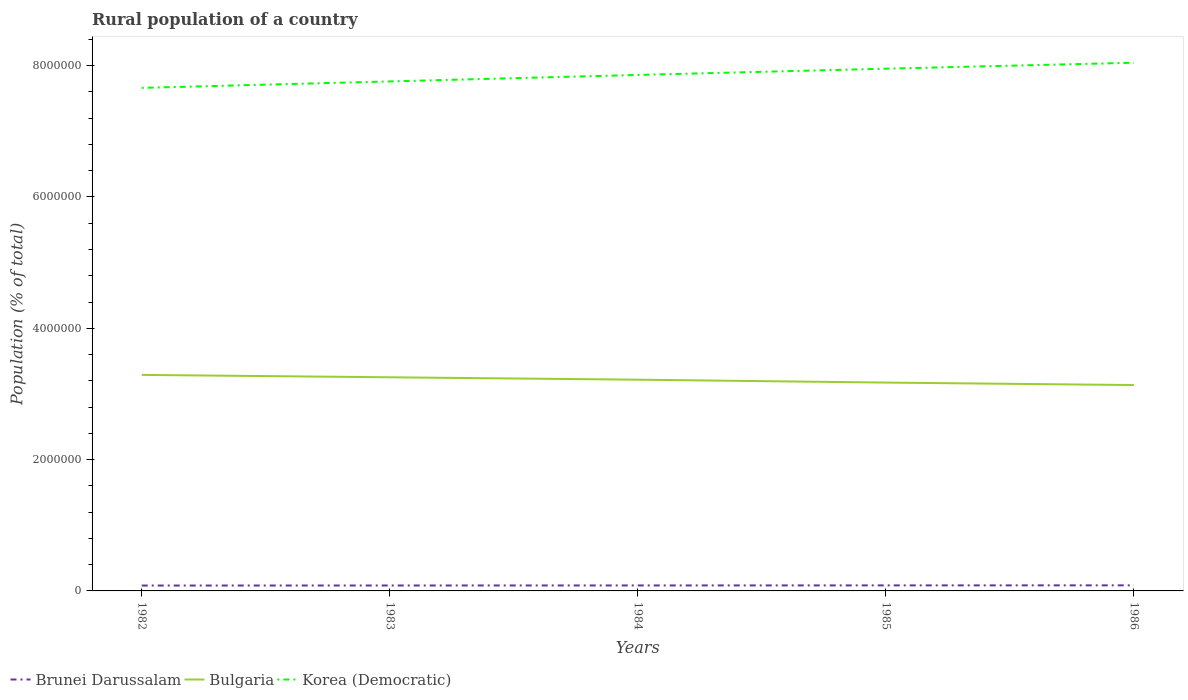Across all years, what is the maximum rural population in Bulgaria?
Give a very brief answer. 3.14e+06. In which year was the rural population in Bulgaria maximum?
Your answer should be very brief. 1986. What is the total rural population in Bulgaria in the graph?
Make the answer very short. 1.55e+05. What is the difference between the highest and the second highest rural population in Bulgaria?
Your answer should be compact. 1.55e+05. How many lines are there?
Your response must be concise. 3. How many years are there in the graph?
Your answer should be very brief. 5. What is the difference between two consecutive major ticks on the Y-axis?
Provide a succinct answer. 2.00e+06. Are the values on the major ticks of Y-axis written in scientific E-notation?
Your response must be concise. No. How many legend labels are there?
Your answer should be compact. 3. What is the title of the graph?
Give a very brief answer. Rural population of a country. What is the label or title of the Y-axis?
Keep it short and to the point. Population (% of total). What is the Population (% of total) of Brunei Darussalam in 1982?
Your answer should be compact. 8.20e+04. What is the Population (% of total) of Bulgaria in 1982?
Make the answer very short. 3.29e+06. What is the Population (% of total) in Korea (Democratic) in 1982?
Provide a succinct answer. 7.66e+06. What is the Population (% of total) of Brunei Darussalam in 1983?
Make the answer very short. 8.27e+04. What is the Population (% of total) of Bulgaria in 1983?
Keep it short and to the point. 3.25e+06. What is the Population (% of total) in Korea (Democratic) in 1983?
Your response must be concise. 7.76e+06. What is the Population (% of total) of Brunei Darussalam in 1984?
Your answer should be very brief. 8.35e+04. What is the Population (% of total) in Bulgaria in 1984?
Your response must be concise. 3.22e+06. What is the Population (% of total) of Korea (Democratic) in 1984?
Your answer should be very brief. 7.86e+06. What is the Population (% of total) in Brunei Darussalam in 1985?
Offer a terse response. 8.42e+04. What is the Population (% of total) of Bulgaria in 1985?
Your answer should be very brief. 3.17e+06. What is the Population (% of total) in Korea (Democratic) in 1985?
Give a very brief answer. 7.95e+06. What is the Population (% of total) in Brunei Darussalam in 1986?
Provide a short and direct response. 8.49e+04. What is the Population (% of total) in Bulgaria in 1986?
Give a very brief answer. 3.14e+06. What is the Population (% of total) of Korea (Democratic) in 1986?
Ensure brevity in your answer.  8.04e+06. Across all years, what is the maximum Population (% of total) in Brunei Darussalam?
Give a very brief answer. 8.49e+04. Across all years, what is the maximum Population (% of total) of Bulgaria?
Make the answer very short. 3.29e+06. Across all years, what is the maximum Population (% of total) of Korea (Democratic)?
Ensure brevity in your answer.  8.04e+06. Across all years, what is the minimum Population (% of total) of Brunei Darussalam?
Provide a short and direct response. 8.20e+04. Across all years, what is the minimum Population (% of total) of Bulgaria?
Keep it short and to the point. 3.14e+06. Across all years, what is the minimum Population (% of total) of Korea (Democratic)?
Keep it short and to the point. 7.66e+06. What is the total Population (% of total) in Brunei Darussalam in the graph?
Provide a short and direct response. 4.17e+05. What is the total Population (% of total) of Bulgaria in the graph?
Your response must be concise. 1.61e+07. What is the total Population (% of total) in Korea (Democratic) in the graph?
Your answer should be compact. 3.93e+07. What is the difference between the Population (% of total) in Brunei Darussalam in 1982 and that in 1983?
Offer a terse response. -777. What is the difference between the Population (% of total) of Bulgaria in 1982 and that in 1983?
Give a very brief answer. 3.64e+04. What is the difference between the Population (% of total) of Korea (Democratic) in 1982 and that in 1983?
Provide a short and direct response. -9.83e+04. What is the difference between the Population (% of total) of Brunei Darussalam in 1982 and that in 1984?
Offer a terse response. -1508. What is the difference between the Population (% of total) in Bulgaria in 1982 and that in 1984?
Ensure brevity in your answer.  7.32e+04. What is the difference between the Population (% of total) in Korea (Democratic) in 1982 and that in 1984?
Keep it short and to the point. -1.97e+05. What is the difference between the Population (% of total) of Brunei Darussalam in 1982 and that in 1985?
Keep it short and to the point. -2242. What is the difference between the Population (% of total) in Bulgaria in 1982 and that in 1985?
Give a very brief answer. 1.17e+05. What is the difference between the Population (% of total) of Korea (Democratic) in 1982 and that in 1985?
Provide a succinct answer. -2.92e+05. What is the difference between the Population (% of total) in Brunei Darussalam in 1982 and that in 1986?
Make the answer very short. -2976. What is the difference between the Population (% of total) of Bulgaria in 1982 and that in 1986?
Provide a succinct answer. 1.55e+05. What is the difference between the Population (% of total) in Korea (Democratic) in 1982 and that in 1986?
Ensure brevity in your answer.  -3.83e+05. What is the difference between the Population (% of total) in Brunei Darussalam in 1983 and that in 1984?
Give a very brief answer. -731. What is the difference between the Population (% of total) in Bulgaria in 1983 and that in 1984?
Keep it short and to the point. 3.68e+04. What is the difference between the Population (% of total) in Korea (Democratic) in 1983 and that in 1984?
Give a very brief answer. -9.88e+04. What is the difference between the Population (% of total) in Brunei Darussalam in 1983 and that in 1985?
Make the answer very short. -1465. What is the difference between the Population (% of total) of Bulgaria in 1983 and that in 1985?
Provide a succinct answer. 8.09e+04. What is the difference between the Population (% of total) of Korea (Democratic) in 1983 and that in 1985?
Your answer should be very brief. -1.94e+05. What is the difference between the Population (% of total) of Brunei Darussalam in 1983 and that in 1986?
Offer a very short reply. -2199. What is the difference between the Population (% of total) in Bulgaria in 1983 and that in 1986?
Provide a short and direct response. 1.18e+05. What is the difference between the Population (% of total) of Korea (Democratic) in 1983 and that in 1986?
Keep it short and to the point. -2.85e+05. What is the difference between the Population (% of total) of Brunei Darussalam in 1984 and that in 1985?
Make the answer very short. -734. What is the difference between the Population (% of total) in Bulgaria in 1984 and that in 1985?
Your answer should be very brief. 4.40e+04. What is the difference between the Population (% of total) in Korea (Democratic) in 1984 and that in 1985?
Provide a short and direct response. -9.53e+04. What is the difference between the Population (% of total) in Brunei Darussalam in 1984 and that in 1986?
Ensure brevity in your answer.  -1468. What is the difference between the Population (% of total) of Bulgaria in 1984 and that in 1986?
Offer a very short reply. 8.15e+04. What is the difference between the Population (% of total) of Korea (Democratic) in 1984 and that in 1986?
Offer a terse response. -1.86e+05. What is the difference between the Population (% of total) in Brunei Darussalam in 1985 and that in 1986?
Provide a succinct answer. -734. What is the difference between the Population (% of total) of Bulgaria in 1985 and that in 1986?
Provide a succinct answer. 3.75e+04. What is the difference between the Population (% of total) in Korea (Democratic) in 1985 and that in 1986?
Provide a succinct answer. -9.08e+04. What is the difference between the Population (% of total) of Brunei Darussalam in 1982 and the Population (% of total) of Bulgaria in 1983?
Keep it short and to the point. -3.17e+06. What is the difference between the Population (% of total) of Brunei Darussalam in 1982 and the Population (% of total) of Korea (Democratic) in 1983?
Provide a succinct answer. -7.68e+06. What is the difference between the Population (% of total) of Bulgaria in 1982 and the Population (% of total) of Korea (Democratic) in 1983?
Your answer should be very brief. -4.47e+06. What is the difference between the Population (% of total) in Brunei Darussalam in 1982 and the Population (% of total) in Bulgaria in 1984?
Ensure brevity in your answer.  -3.14e+06. What is the difference between the Population (% of total) in Brunei Darussalam in 1982 and the Population (% of total) in Korea (Democratic) in 1984?
Provide a succinct answer. -7.78e+06. What is the difference between the Population (% of total) in Bulgaria in 1982 and the Population (% of total) in Korea (Democratic) in 1984?
Provide a succinct answer. -4.57e+06. What is the difference between the Population (% of total) in Brunei Darussalam in 1982 and the Population (% of total) in Bulgaria in 1985?
Provide a short and direct response. -3.09e+06. What is the difference between the Population (% of total) of Brunei Darussalam in 1982 and the Population (% of total) of Korea (Democratic) in 1985?
Your response must be concise. -7.87e+06. What is the difference between the Population (% of total) in Bulgaria in 1982 and the Population (% of total) in Korea (Democratic) in 1985?
Your answer should be very brief. -4.66e+06. What is the difference between the Population (% of total) in Brunei Darussalam in 1982 and the Population (% of total) in Bulgaria in 1986?
Offer a terse response. -3.05e+06. What is the difference between the Population (% of total) in Brunei Darussalam in 1982 and the Population (% of total) in Korea (Democratic) in 1986?
Keep it short and to the point. -7.96e+06. What is the difference between the Population (% of total) of Bulgaria in 1982 and the Population (% of total) of Korea (Democratic) in 1986?
Ensure brevity in your answer.  -4.75e+06. What is the difference between the Population (% of total) in Brunei Darussalam in 1983 and the Population (% of total) in Bulgaria in 1984?
Offer a terse response. -3.13e+06. What is the difference between the Population (% of total) in Brunei Darussalam in 1983 and the Population (% of total) in Korea (Democratic) in 1984?
Your response must be concise. -7.78e+06. What is the difference between the Population (% of total) of Bulgaria in 1983 and the Population (% of total) of Korea (Democratic) in 1984?
Keep it short and to the point. -4.60e+06. What is the difference between the Population (% of total) in Brunei Darussalam in 1983 and the Population (% of total) in Bulgaria in 1985?
Your answer should be compact. -3.09e+06. What is the difference between the Population (% of total) in Brunei Darussalam in 1983 and the Population (% of total) in Korea (Democratic) in 1985?
Offer a very short reply. -7.87e+06. What is the difference between the Population (% of total) in Bulgaria in 1983 and the Population (% of total) in Korea (Democratic) in 1985?
Offer a terse response. -4.70e+06. What is the difference between the Population (% of total) of Brunei Darussalam in 1983 and the Population (% of total) of Bulgaria in 1986?
Make the answer very short. -3.05e+06. What is the difference between the Population (% of total) in Brunei Darussalam in 1983 and the Population (% of total) in Korea (Democratic) in 1986?
Your answer should be compact. -7.96e+06. What is the difference between the Population (% of total) of Bulgaria in 1983 and the Population (% of total) of Korea (Democratic) in 1986?
Offer a terse response. -4.79e+06. What is the difference between the Population (% of total) of Brunei Darussalam in 1984 and the Population (% of total) of Bulgaria in 1985?
Keep it short and to the point. -3.09e+06. What is the difference between the Population (% of total) of Brunei Darussalam in 1984 and the Population (% of total) of Korea (Democratic) in 1985?
Offer a very short reply. -7.87e+06. What is the difference between the Population (% of total) of Bulgaria in 1984 and the Population (% of total) of Korea (Democratic) in 1985?
Your response must be concise. -4.74e+06. What is the difference between the Population (% of total) of Brunei Darussalam in 1984 and the Population (% of total) of Bulgaria in 1986?
Ensure brevity in your answer.  -3.05e+06. What is the difference between the Population (% of total) in Brunei Darussalam in 1984 and the Population (% of total) in Korea (Democratic) in 1986?
Provide a succinct answer. -7.96e+06. What is the difference between the Population (% of total) in Bulgaria in 1984 and the Population (% of total) in Korea (Democratic) in 1986?
Make the answer very short. -4.83e+06. What is the difference between the Population (% of total) in Brunei Darussalam in 1985 and the Population (% of total) in Bulgaria in 1986?
Offer a very short reply. -3.05e+06. What is the difference between the Population (% of total) in Brunei Darussalam in 1985 and the Population (% of total) in Korea (Democratic) in 1986?
Your answer should be compact. -7.96e+06. What is the difference between the Population (% of total) in Bulgaria in 1985 and the Population (% of total) in Korea (Democratic) in 1986?
Offer a very short reply. -4.87e+06. What is the average Population (% of total) of Brunei Darussalam per year?
Your response must be concise. 8.35e+04. What is the average Population (% of total) in Bulgaria per year?
Your answer should be very brief. 3.21e+06. What is the average Population (% of total) of Korea (Democratic) per year?
Offer a very short reply. 7.86e+06. In the year 1982, what is the difference between the Population (% of total) in Brunei Darussalam and Population (% of total) in Bulgaria?
Offer a terse response. -3.21e+06. In the year 1982, what is the difference between the Population (% of total) in Brunei Darussalam and Population (% of total) in Korea (Democratic)?
Your answer should be very brief. -7.58e+06. In the year 1982, what is the difference between the Population (% of total) of Bulgaria and Population (% of total) of Korea (Democratic)?
Ensure brevity in your answer.  -4.37e+06. In the year 1983, what is the difference between the Population (% of total) in Brunei Darussalam and Population (% of total) in Bulgaria?
Give a very brief answer. -3.17e+06. In the year 1983, what is the difference between the Population (% of total) of Brunei Darussalam and Population (% of total) of Korea (Democratic)?
Provide a succinct answer. -7.68e+06. In the year 1983, what is the difference between the Population (% of total) of Bulgaria and Population (% of total) of Korea (Democratic)?
Provide a succinct answer. -4.51e+06. In the year 1984, what is the difference between the Population (% of total) of Brunei Darussalam and Population (% of total) of Bulgaria?
Your answer should be compact. -3.13e+06. In the year 1984, what is the difference between the Population (% of total) of Brunei Darussalam and Population (% of total) of Korea (Democratic)?
Provide a succinct answer. -7.77e+06. In the year 1984, what is the difference between the Population (% of total) of Bulgaria and Population (% of total) of Korea (Democratic)?
Your response must be concise. -4.64e+06. In the year 1985, what is the difference between the Population (% of total) in Brunei Darussalam and Population (% of total) in Bulgaria?
Offer a very short reply. -3.09e+06. In the year 1985, what is the difference between the Population (% of total) of Brunei Darussalam and Population (% of total) of Korea (Democratic)?
Ensure brevity in your answer.  -7.87e+06. In the year 1985, what is the difference between the Population (% of total) in Bulgaria and Population (% of total) in Korea (Democratic)?
Provide a succinct answer. -4.78e+06. In the year 1986, what is the difference between the Population (% of total) in Brunei Darussalam and Population (% of total) in Bulgaria?
Your response must be concise. -3.05e+06. In the year 1986, what is the difference between the Population (% of total) of Brunei Darussalam and Population (% of total) of Korea (Democratic)?
Your response must be concise. -7.96e+06. In the year 1986, what is the difference between the Population (% of total) in Bulgaria and Population (% of total) in Korea (Democratic)?
Provide a succinct answer. -4.91e+06. What is the ratio of the Population (% of total) in Brunei Darussalam in 1982 to that in 1983?
Make the answer very short. 0.99. What is the ratio of the Population (% of total) in Bulgaria in 1982 to that in 1983?
Offer a very short reply. 1.01. What is the ratio of the Population (% of total) in Korea (Democratic) in 1982 to that in 1983?
Your response must be concise. 0.99. What is the ratio of the Population (% of total) of Brunei Darussalam in 1982 to that in 1984?
Make the answer very short. 0.98. What is the ratio of the Population (% of total) in Bulgaria in 1982 to that in 1984?
Provide a succinct answer. 1.02. What is the ratio of the Population (% of total) in Korea (Democratic) in 1982 to that in 1984?
Give a very brief answer. 0.97. What is the ratio of the Population (% of total) in Brunei Darussalam in 1982 to that in 1985?
Offer a terse response. 0.97. What is the ratio of the Population (% of total) in Bulgaria in 1982 to that in 1985?
Make the answer very short. 1.04. What is the ratio of the Population (% of total) of Korea (Democratic) in 1982 to that in 1985?
Your answer should be compact. 0.96. What is the ratio of the Population (% of total) of Brunei Darussalam in 1982 to that in 1986?
Keep it short and to the point. 0.96. What is the ratio of the Population (% of total) of Bulgaria in 1982 to that in 1986?
Keep it short and to the point. 1.05. What is the ratio of the Population (% of total) of Korea (Democratic) in 1982 to that in 1986?
Offer a terse response. 0.95. What is the ratio of the Population (% of total) of Bulgaria in 1983 to that in 1984?
Your answer should be very brief. 1.01. What is the ratio of the Population (% of total) in Korea (Democratic) in 1983 to that in 1984?
Your answer should be very brief. 0.99. What is the ratio of the Population (% of total) of Brunei Darussalam in 1983 to that in 1985?
Provide a succinct answer. 0.98. What is the ratio of the Population (% of total) of Bulgaria in 1983 to that in 1985?
Ensure brevity in your answer.  1.03. What is the ratio of the Population (% of total) of Korea (Democratic) in 1983 to that in 1985?
Give a very brief answer. 0.98. What is the ratio of the Population (% of total) in Brunei Darussalam in 1983 to that in 1986?
Your response must be concise. 0.97. What is the ratio of the Population (% of total) in Bulgaria in 1983 to that in 1986?
Give a very brief answer. 1.04. What is the ratio of the Population (% of total) in Korea (Democratic) in 1983 to that in 1986?
Keep it short and to the point. 0.96. What is the ratio of the Population (% of total) in Bulgaria in 1984 to that in 1985?
Your response must be concise. 1.01. What is the ratio of the Population (% of total) in Korea (Democratic) in 1984 to that in 1985?
Offer a very short reply. 0.99. What is the ratio of the Population (% of total) in Brunei Darussalam in 1984 to that in 1986?
Your response must be concise. 0.98. What is the ratio of the Population (% of total) of Bulgaria in 1984 to that in 1986?
Ensure brevity in your answer.  1.03. What is the ratio of the Population (% of total) of Korea (Democratic) in 1984 to that in 1986?
Your answer should be very brief. 0.98. What is the ratio of the Population (% of total) in Brunei Darussalam in 1985 to that in 1986?
Ensure brevity in your answer.  0.99. What is the ratio of the Population (% of total) of Korea (Democratic) in 1985 to that in 1986?
Provide a succinct answer. 0.99. What is the difference between the highest and the second highest Population (% of total) of Brunei Darussalam?
Offer a very short reply. 734. What is the difference between the highest and the second highest Population (% of total) in Bulgaria?
Keep it short and to the point. 3.64e+04. What is the difference between the highest and the second highest Population (% of total) of Korea (Democratic)?
Your response must be concise. 9.08e+04. What is the difference between the highest and the lowest Population (% of total) of Brunei Darussalam?
Give a very brief answer. 2976. What is the difference between the highest and the lowest Population (% of total) of Bulgaria?
Your answer should be compact. 1.55e+05. What is the difference between the highest and the lowest Population (% of total) in Korea (Democratic)?
Offer a very short reply. 3.83e+05. 